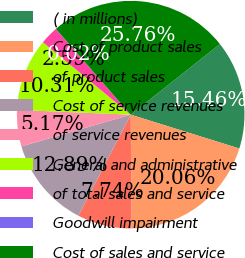<chart> <loc_0><loc_0><loc_500><loc_500><pie_chart><fcel>( in millions)<fcel>Cost of product sales<fcel>of product sales<fcel>Cost of service revenues<fcel>of service revenues<fcel>General and administrative<fcel>of total sales and service<fcel>Goodwill impairment<fcel>Cost of sales and service<nl><fcel>15.46%<fcel>20.06%<fcel>7.74%<fcel>12.89%<fcel>5.17%<fcel>10.31%<fcel>2.59%<fcel>0.02%<fcel>25.76%<nl></chart> 